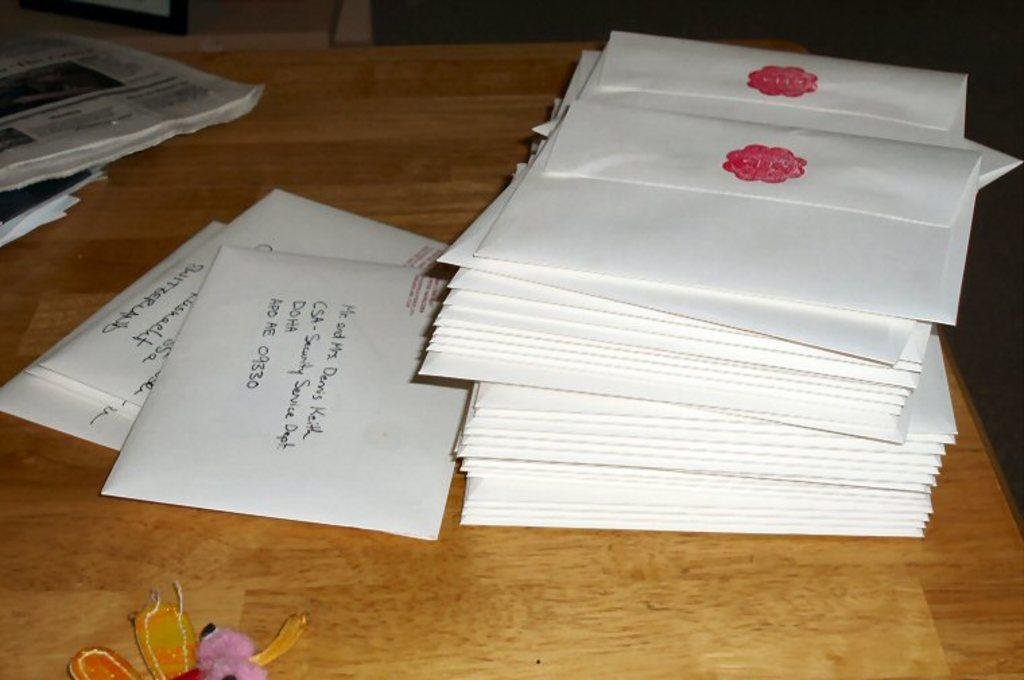<image>
Render a clear and concise summary of the photo. the letters DOHA are on the white note 